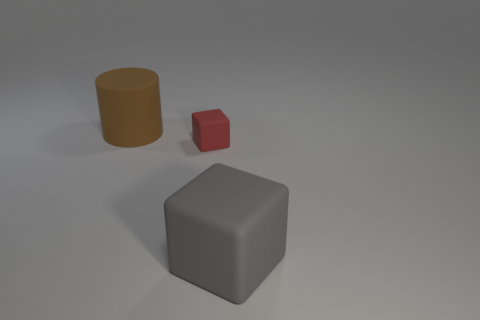Subtract 0 yellow cubes. How many objects are left? 3 Subtract all blocks. How many objects are left? 1 Subtract 1 cubes. How many cubes are left? 1 Subtract all purple blocks. Subtract all green balls. How many blocks are left? 2 Subtract all blue cylinders. How many gray cubes are left? 1 Subtract all small cubes. Subtract all small red objects. How many objects are left? 1 Add 2 small rubber cubes. How many small rubber cubes are left? 3 Add 2 small red metal spheres. How many small red metal spheres exist? 2 Add 3 brown things. How many objects exist? 6 